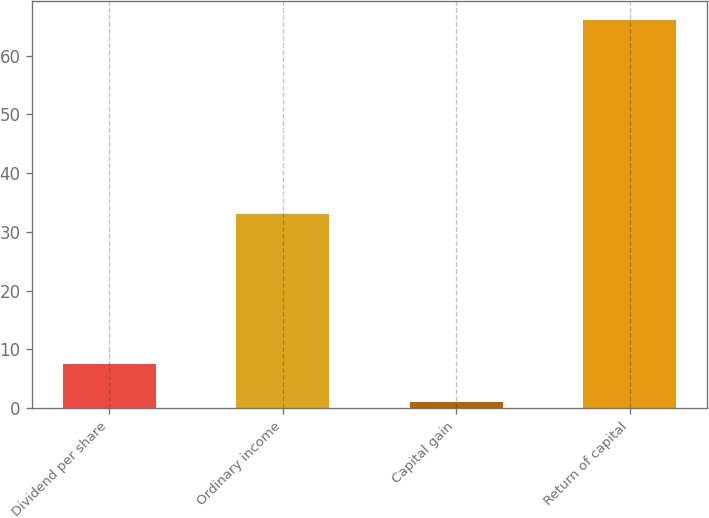<chart> <loc_0><loc_0><loc_500><loc_500><bar_chart><fcel>Dividend per share<fcel>Ordinary income<fcel>Capital gain<fcel>Return of capital<nl><fcel>7.5<fcel>33<fcel>1<fcel>66<nl></chart> 